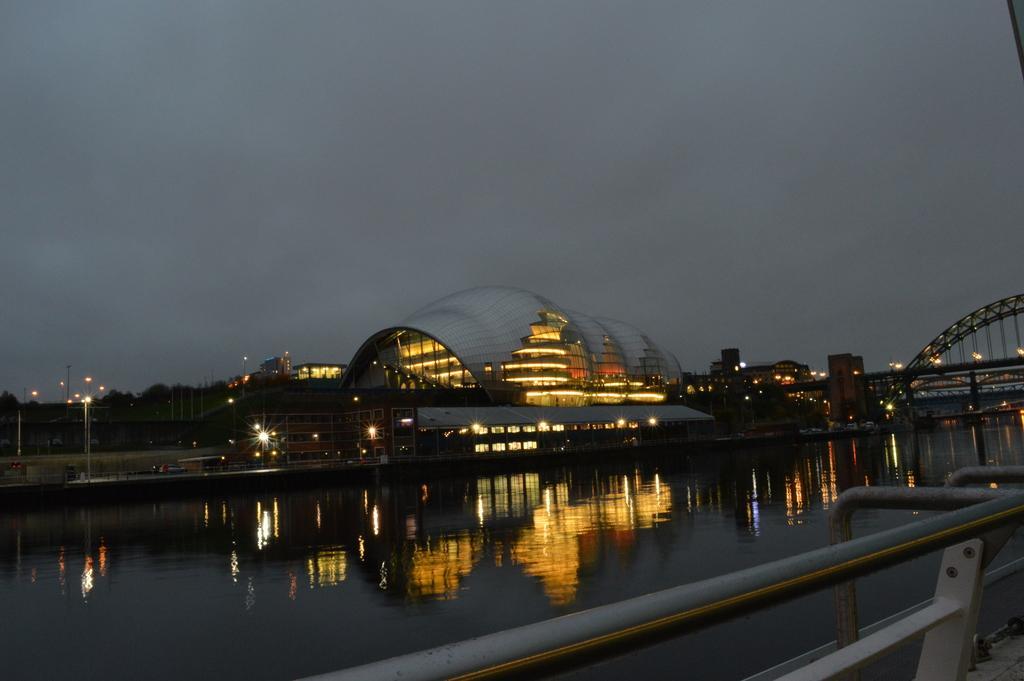Can you describe this image briefly? In this image I can see this is water, in the middle it's a very big ship with lights. On the right side there is the bridge, at the top there is the sky. 